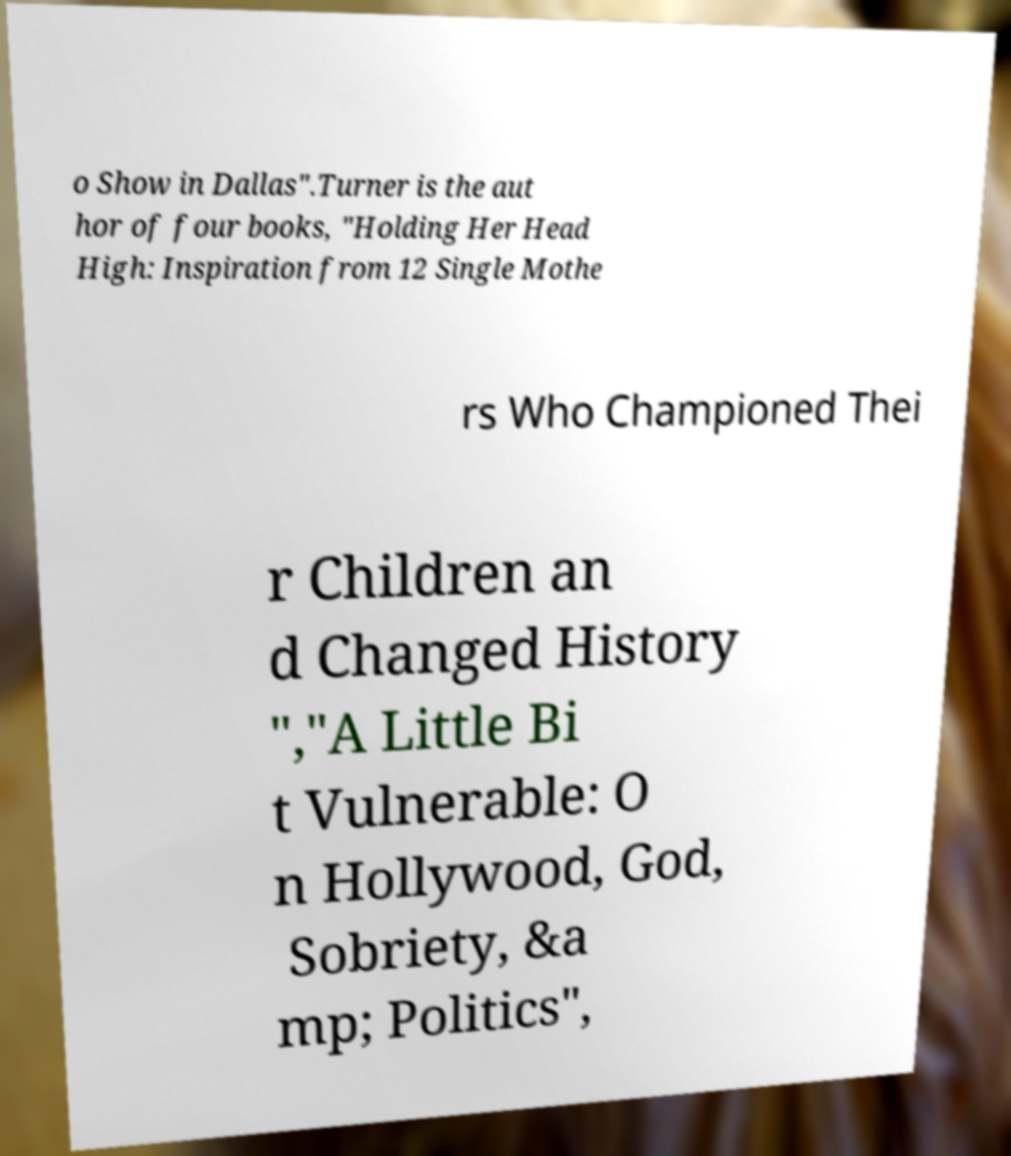What messages or text are displayed in this image? I need them in a readable, typed format. o Show in Dallas".Turner is the aut hor of four books, "Holding Her Head High: Inspiration from 12 Single Mothe rs Who Championed Thei r Children an d Changed History ","A Little Bi t Vulnerable: O n Hollywood, God, Sobriety, &a mp; Politics", 